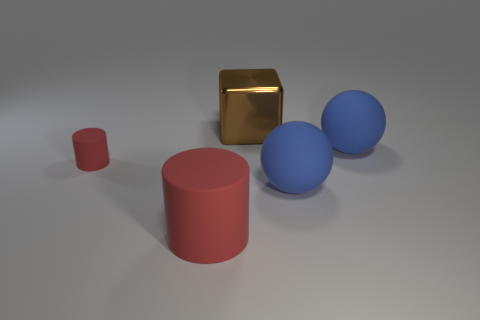What number of other objects are the same size as the brown thing? There are two blue spheres in the image that appear to be of the same size as the brown cube. 